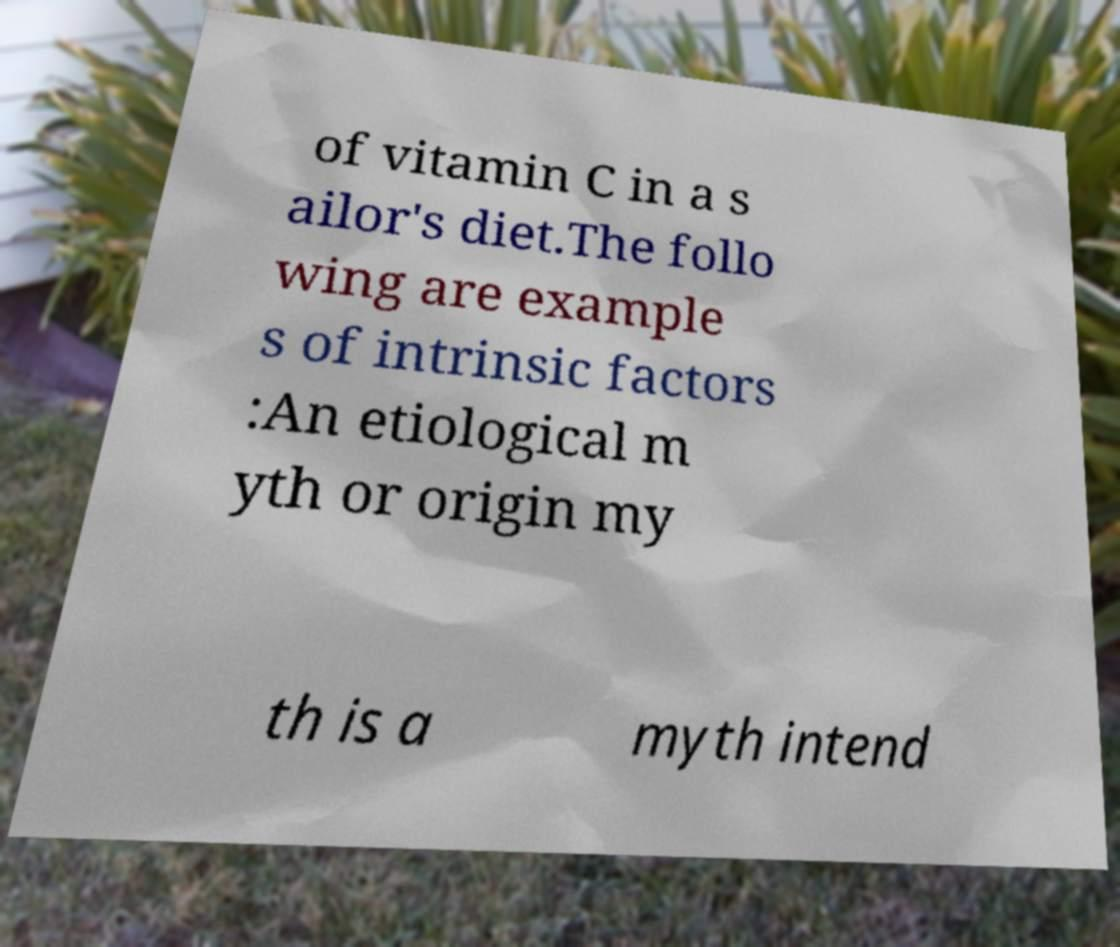Can you accurately transcribe the text from the provided image for me? of vitamin C in a s ailor's diet.The follo wing are example s of intrinsic factors :An etiological m yth or origin my th is a myth intend 